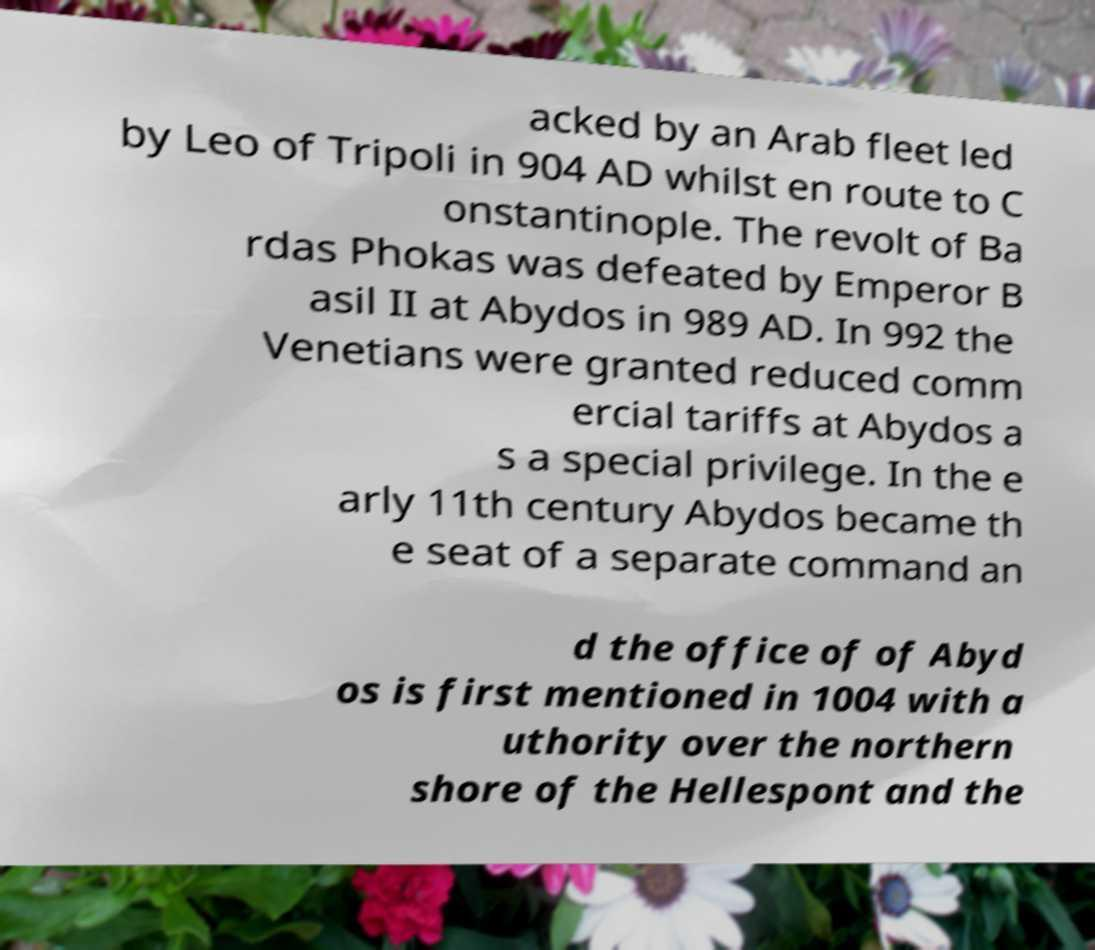Can you read and provide the text displayed in the image?This photo seems to have some interesting text. Can you extract and type it out for me? acked by an Arab fleet led by Leo of Tripoli in 904 AD whilst en route to C onstantinople. The revolt of Ba rdas Phokas was defeated by Emperor B asil II at Abydos in 989 AD. In 992 the Venetians were granted reduced comm ercial tariffs at Abydos a s a special privilege. In the e arly 11th century Abydos became th e seat of a separate command an d the office of of Abyd os is first mentioned in 1004 with a uthority over the northern shore of the Hellespont and the 